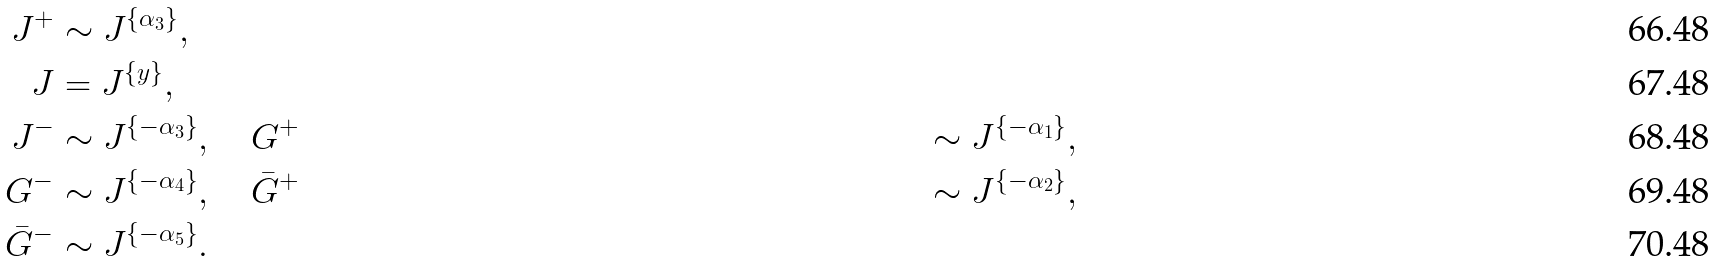Convert formula to latex. <formula><loc_0><loc_0><loc_500><loc_500>J ^ { + } & \sim J ^ { \{ \alpha _ { 3 } \} } , \\ J & = J ^ { \{ y \} } , \\ J ^ { - } & \sim J ^ { \{ { - \alpha _ { 3 } } \} } , \quad G ^ { + } & \sim J ^ { \{ - \alpha _ { 1 } \} } , \\ G ^ { - } & \sim J ^ { \{ { - \alpha _ { 4 } } \} } , \quad \bar { G } ^ { + } & \sim J ^ { \{ - \alpha _ { 2 } \} } , \\ \bar { G } ^ { - } & \sim J ^ { \{ { - \alpha _ { 5 } } \} } .</formula> 